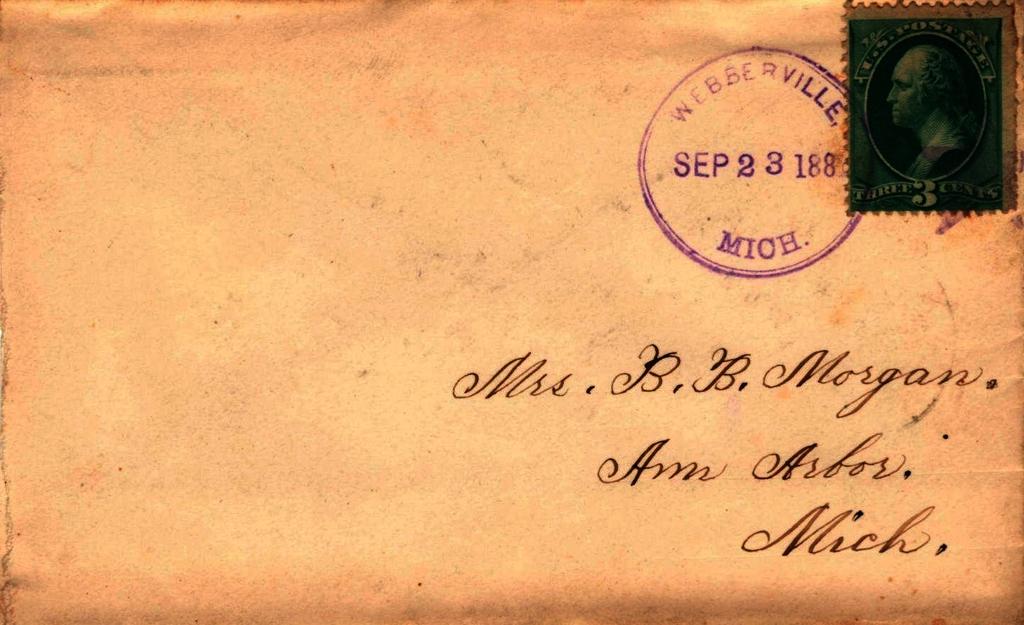Who is the letter for?
Your answer should be compact. Mrs. b.b. morgan. In what month was the letter sent?
Give a very brief answer. September. 